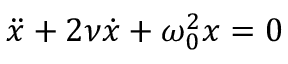Convert formula to latex. <formula><loc_0><loc_0><loc_500><loc_500>\ddot { x } + 2 \nu \dot { x } + \omega _ { 0 } ^ { 2 } x = 0</formula> 